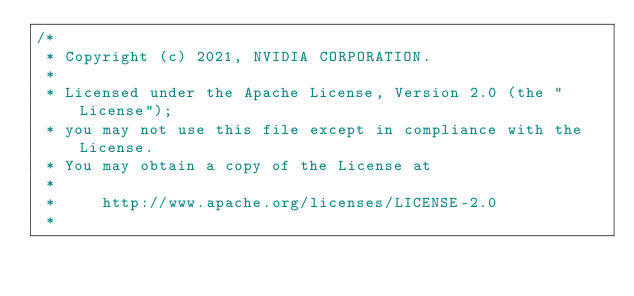<code> <loc_0><loc_0><loc_500><loc_500><_Cuda_>/*
 * Copyright (c) 2021, NVIDIA CORPORATION.
 *
 * Licensed under the Apache License, Version 2.0 (the "License");
 * you may not use this file except in compliance with the License.
 * You may obtain a copy of the License at
 *
 *     http://www.apache.org/licenses/LICENSE-2.0
 *</code> 